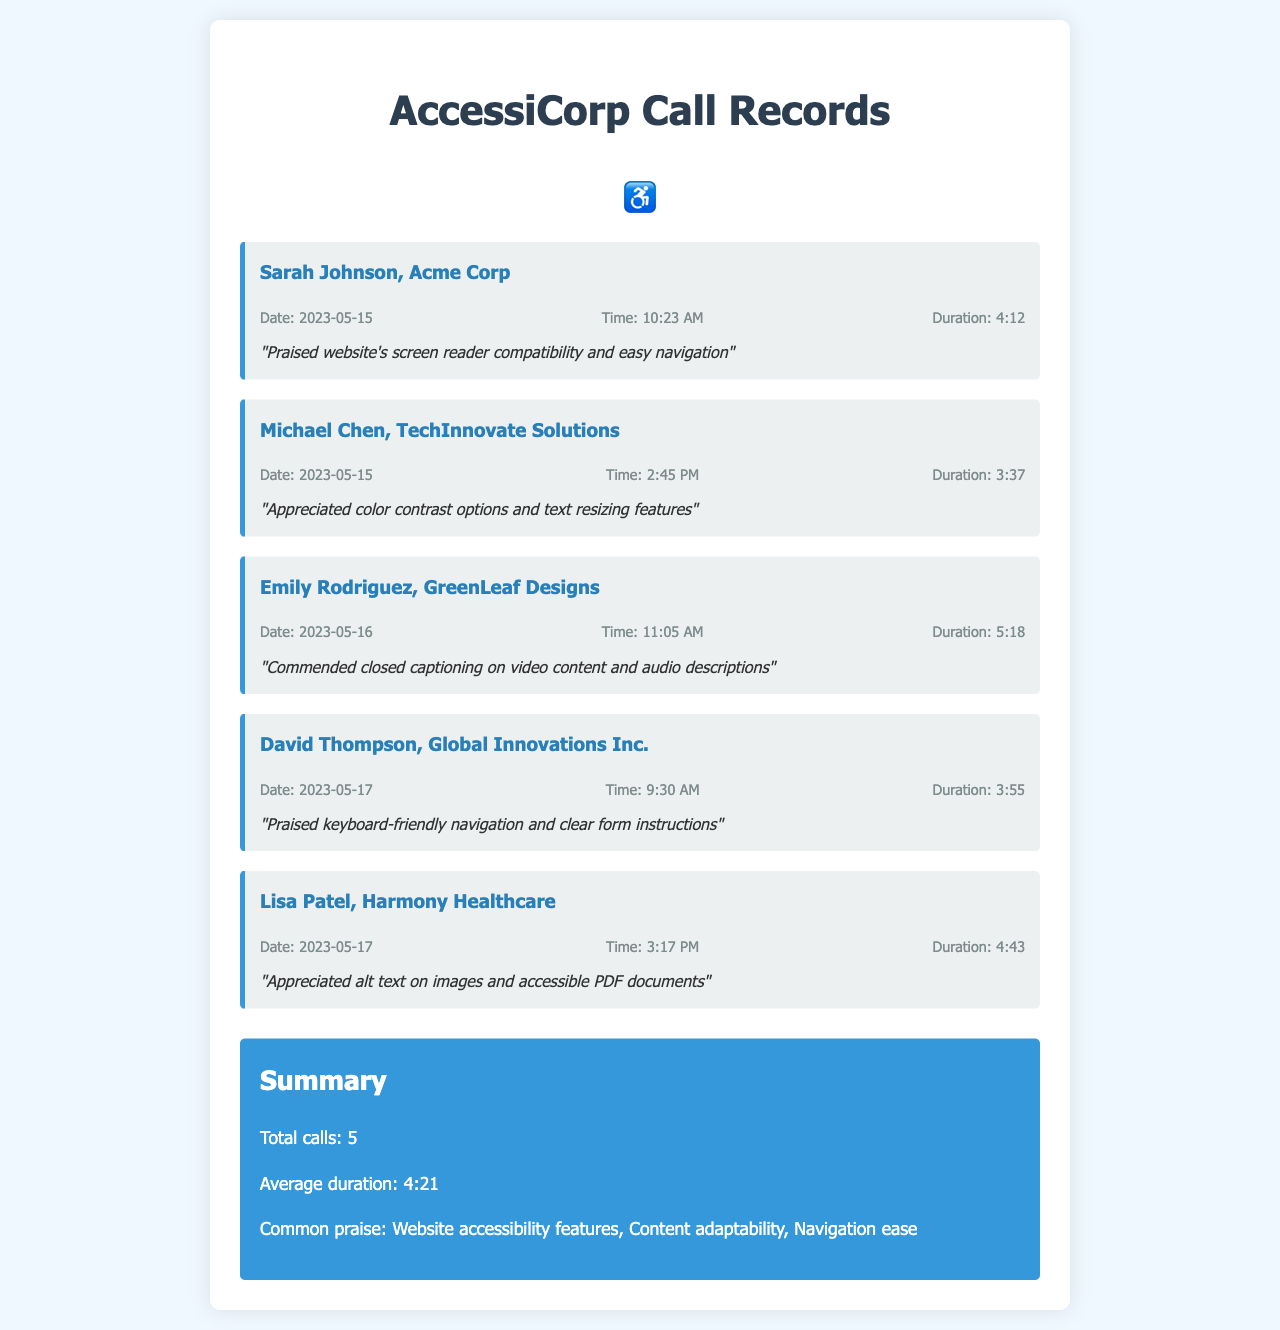What is the date of Sarah Johnson's call? Sarah Johnson's call is recorded with a specific date of 2023-05-15.
Answer: 2023-05-15 How long was the call with Michael Chen? The duration of the call with Michael Chen is provided in the document as 3:37.
Answer: 3:37 What feedback did Emily Rodriguez give? Emily Rodriguez's feedback highlights the closed captioning on video content and audio descriptions.
Answer: Commended closed captioning on video content and audio descriptions Who is the client that praised keyboard-friendly navigation? The client who praised keyboard-friendly navigation is David Thompson from Global Innovations Inc.
Answer: David Thompson What is the average duration of the calls? The average duration of all recorded calls is calculated and stated as 4:21.
Answer: 4:21 Which feature was commonly praised across the calls? Common praise mentioned in the summary includes website accessibility features.
Answer: Website accessibility features How many total calls were recorded? The document summarizes the total number of calls recorded as 5.
Answer: 5 What was the time of the call with Lisa Patel? The time of Lisa Patel's call is recorded as 3:17 PM.
Answer: 3:17 PM What accessibility feature was appreciated by Lisa Patel? Lisa Patel appreciated the alt text on images and accessible PDF documents.
Answer: Alt text on images and accessible PDF documents 